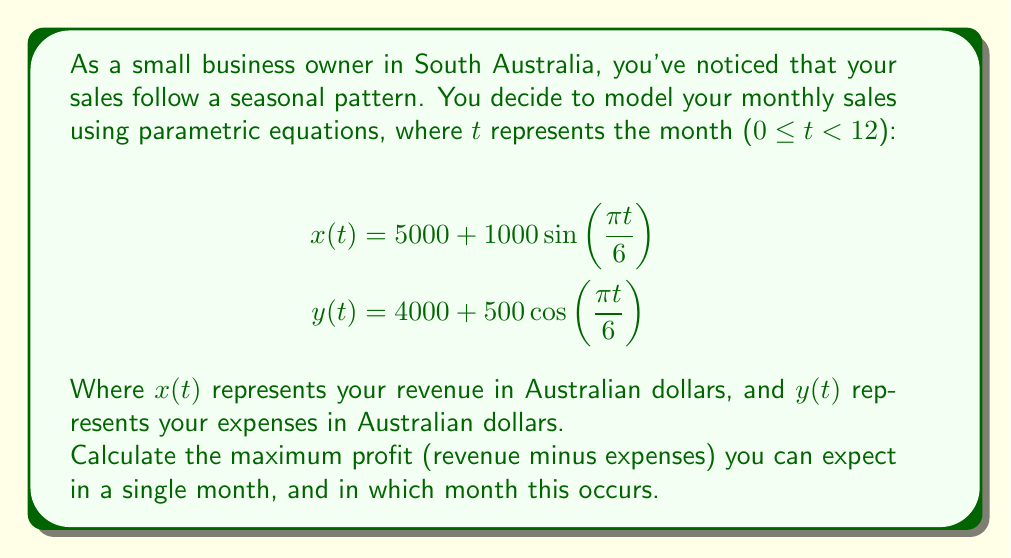Show me your answer to this math problem. To solve this problem, we need to follow these steps:

1) First, let's define the profit function $P(t)$ as the difference between revenue and expenses:

   $$P(t) = x(t) - y(t) = [5000 + 1000\sin(\frac{\pi t}{6})] - [4000 + 500\cos(\frac{\pi t}{6})]$$
   $$P(t) = 1000 + 1000\sin(\frac{\pi t}{6}) - 500\cos(\frac{\pi t}{6})$$

2) To find the maximum profit, we need to find the value of $t$ where $\frac{dP}{dt} = 0$:

   $$\frac{dP}{dt} = 1000 \cdot \frac{\pi}{6}\cos(\frac{\pi t}{6}) + 500 \cdot \frac{\pi}{6}\sin(\frac{\pi t}{6}) = 0$$

3) Simplify:

   $$1000\cos(\frac{\pi t}{6}) + 500\sin(\frac{\pi t}{6}) = 0$$
   $$2\cos(\frac{\pi t}{6}) + \sin(\frac{\pi t}{6}) = 0$$

4) This equation can be solved using the tangent half-angle substitution:

   $$\tan(\frac{\pi t}{12}) = 1$$

5) Solving this:

   $$\frac{\pi t}{12} = \arctan(1) = \frac{\pi}{4}$$
   $$t = 3$$

6) To confirm this is a maximum, we can check the second derivative is negative at this point (omitted for brevity).

7) The maximum profit occurs when $t = 3$, which corresponds to the fourth month (April, as January is month 0).

8) To find the maximum profit value, we substitute $t = 3$ into our profit function:

   $$P(3) = 1000 + 1000\sin(\frac{\pi}{2}) - 500\cos(\frac{\pi}{2}) = 2000$$

Therefore, the maximum profit is 2000 Australian dollars and occurs in April.
Answer: The maximum profit is 2000 Australian dollars and occurs in April (the 4th month of the year). 